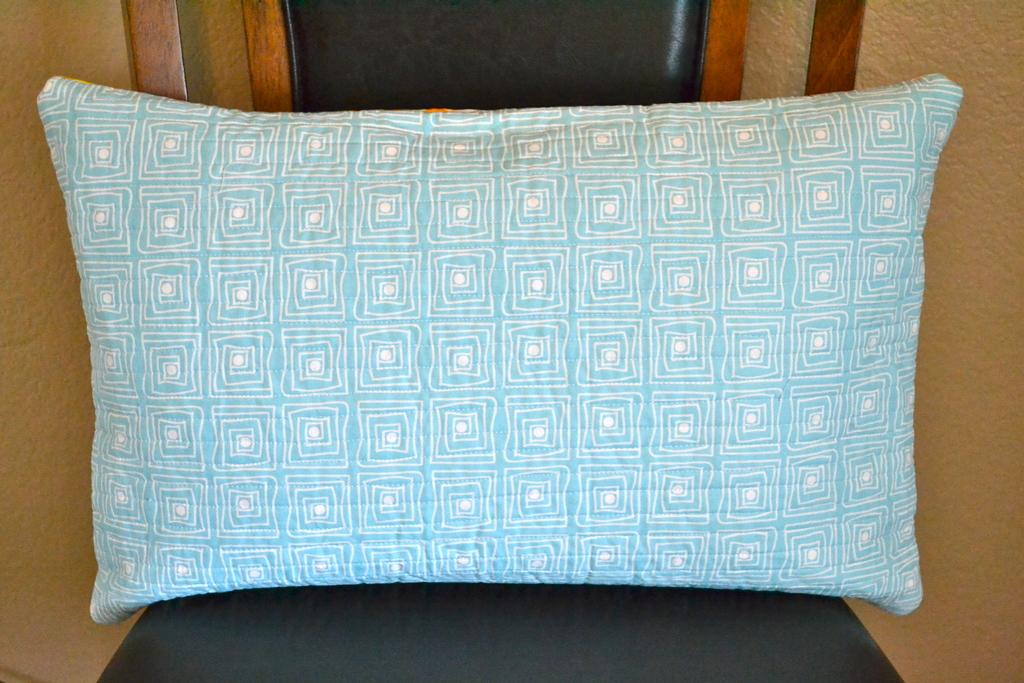What piece of furniture is present in the image? There is a chair in the image. What is placed on the chair? There is a pillow on the chair. What can be seen behind the chair? There is a wall behind the chair. What type of smell can be detected from the pillow in the image? There is no information about the smell of the pillow in the image, so it cannot be determined. 